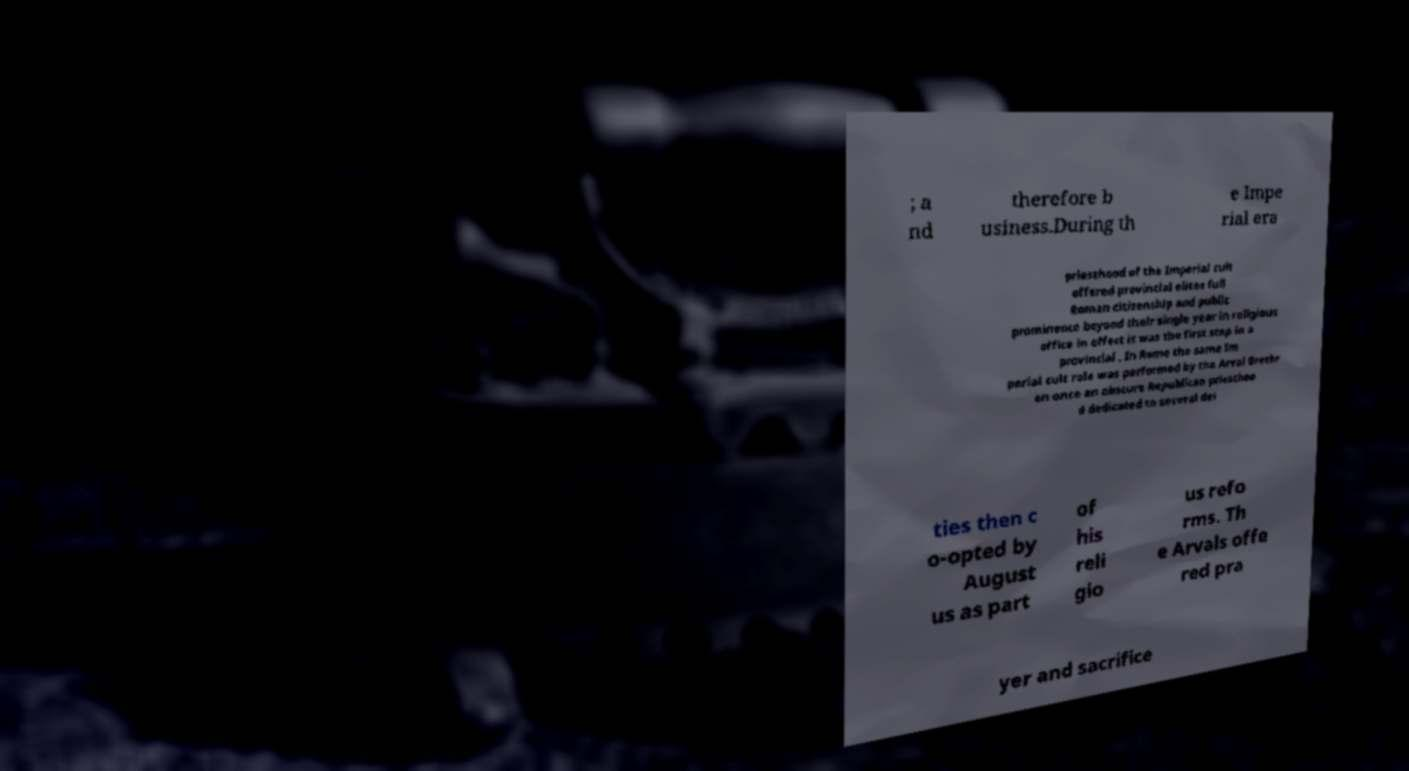I need the written content from this picture converted into text. Can you do that? ; a nd therefore b usiness.During th e Impe rial era priesthood of the Imperial cult offered provincial elites full Roman citizenship and public prominence beyond their single year in religious office in effect it was the first step in a provincial . In Rome the same Im perial cult role was performed by the Arval Brethr en once an obscure Republican priesthoo d dedicated to several dei ties then c o-opted by August us as part of his reli gio us refo rms. Th e Arvals offe red pra yer and sacrifice 